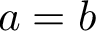Convert formula to latex. <formula><loc_0><loc_0><loc_500><loc_500>a = b</formula> 